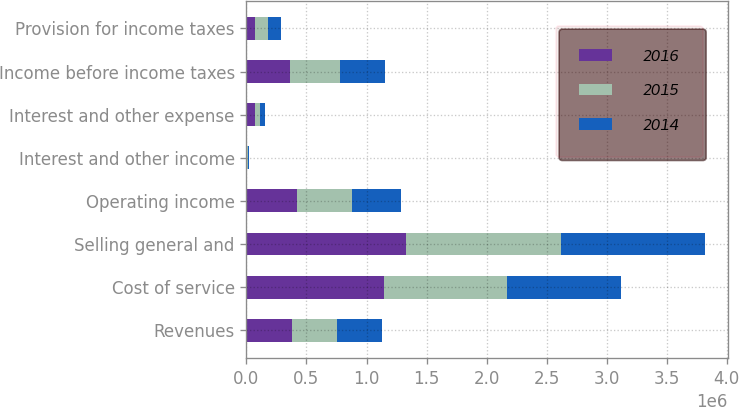Convert chart to OTSL. <chart><loc_0><loc_0><loc_500><loc_500><stacked_bar_chart><ecel><fcel>Revenues<fcel>Cost of service<fcel>Selling general and<fcel>Operating income<fcel>Interest and other income<fcel>Interest and other expense<fcel>Income before income taxes<fcel>Provision for income taxes<nl><fcel>2016<fcel>377350<fcel>1.14764e+06<fcel>1.32557e+06<fcel>424944<fcel>5284<fcel>69316<fcel>360912<fcel>70695<nl><fcel>2015<fcel>377350<fcel>1.02211e+06<fcel>1.29501e+06<fcel>456597<fcel>4949<fcel>44436<fcel>417110<fcel>107995<nl><fcel>2014<fcel>377350<fcel>952225<fcel>1.19651e+06<fcel>405499<fcel>13663<fcel>41812<fcel>377350<fcel>107398<nl></chart> 